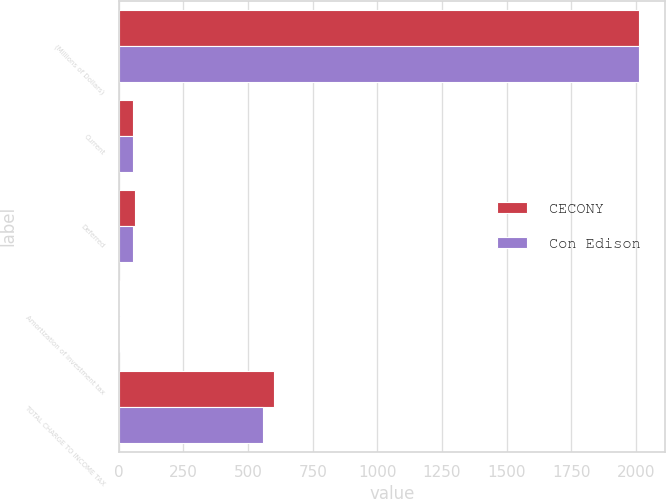Convert chart to OTSL. <chart><loc_0><loc_0><loc_500><loc_500><stacked_bar_chart><ecel><fcel>(Millions of Dollars)<fcel>Current<fcel>Deferred<fcel>Amortization of investment tax<fcel>TOTAL CHARGE TO INCOME TAX<nl><fcel>CECONY<fcel>2011<fcel>56<fcel>63<fcel>6<fcel>600<nl><fcel>Con Edison<fcel>2011<fcel>53<fcel>55<fcel>6<fcel>558<nl></chart> 